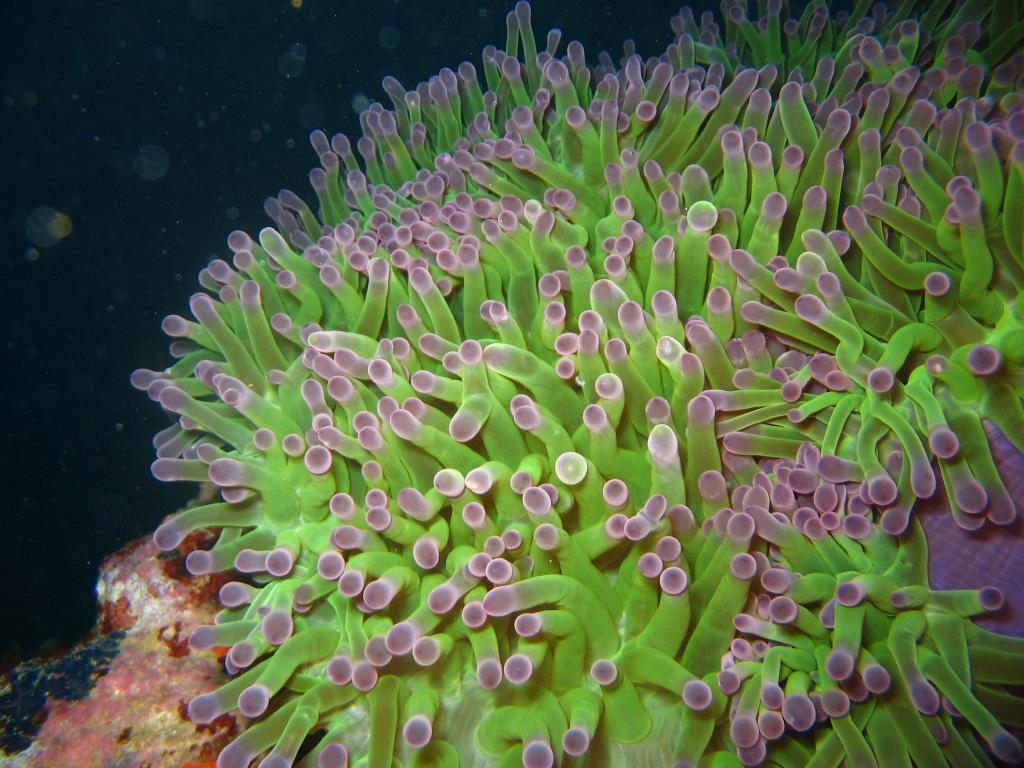What type of underwater environment is depicted in the image? There is a coral reef in the image. Can you describe the colors and patterns of the coral reef? The colors and patterns of the coral reef are diverse and vibrant, with various shades of pink, purple, blue, and green. Are there any marine animals visible in the image? The provided facts do not mention any marine animals, so we cannot determine their presence from the information given. What is the name of the person who is about to kiss the coral reef in the image? There is no person present in the image, let alone someone about to kiss the coral reef. 